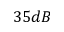Convert formula to latex. <formula><loc_0><loc_0><loc_500><loc_500>3 5 d B</formula> 